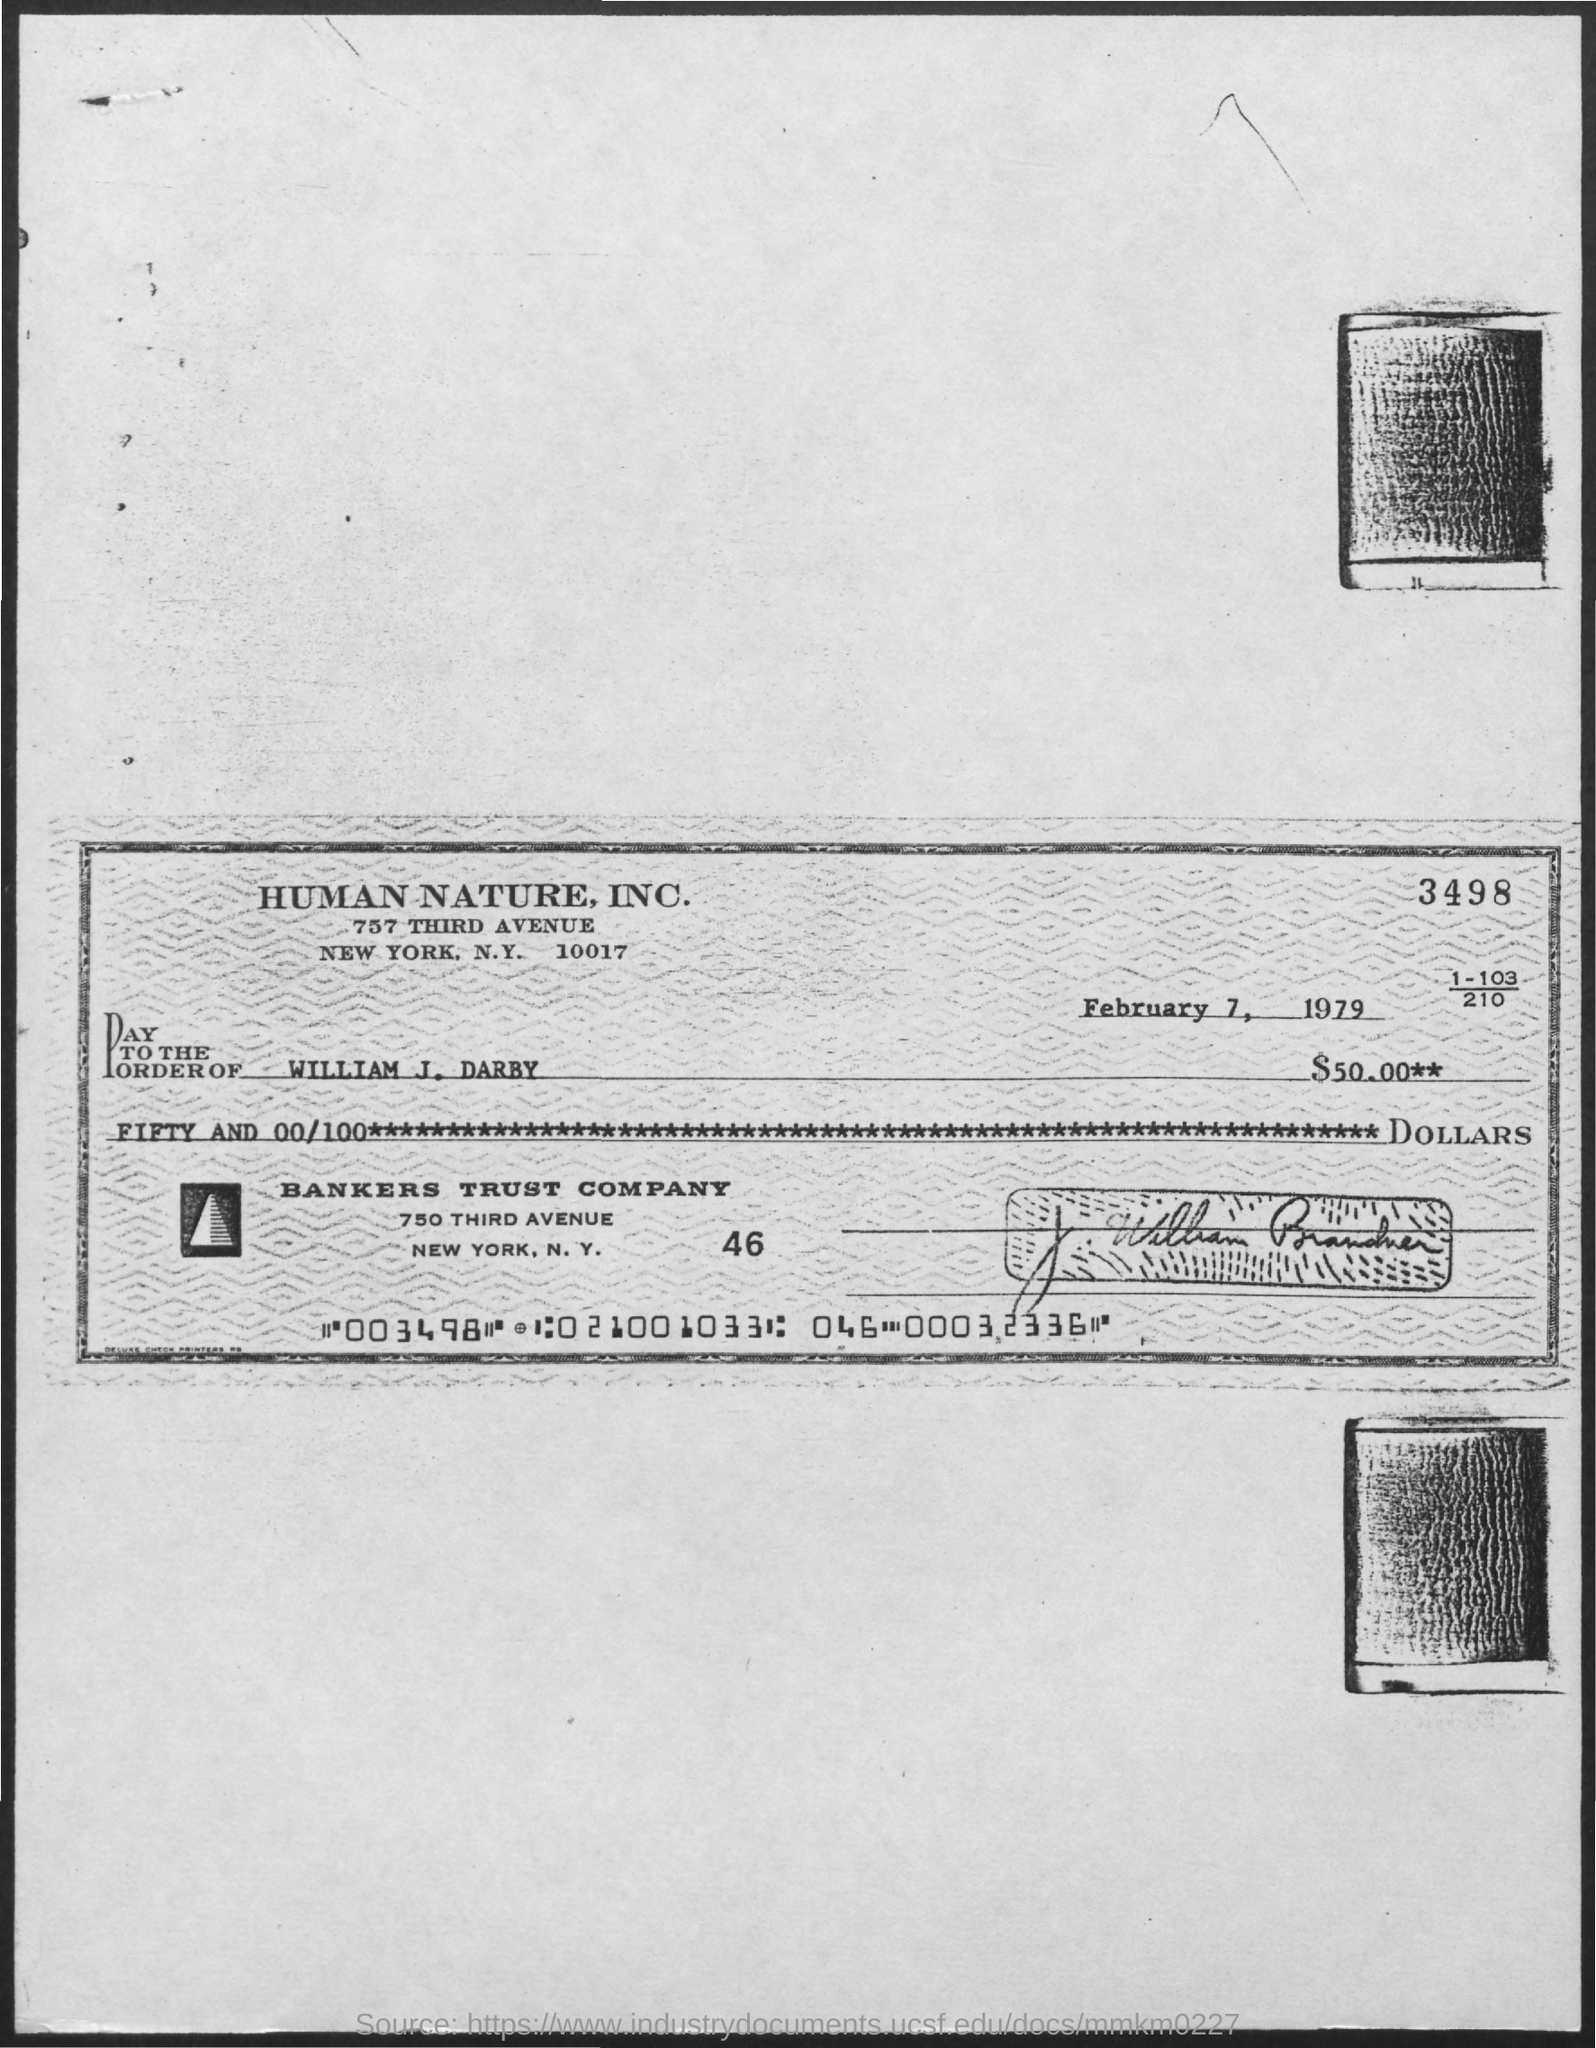What is the date mentioned in the given page ?
Offer a very short reply. February 7, 1979. What is the amount given in the page?
Ensure brevity in your answer.  $50.00. 